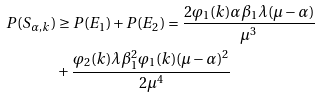<formula> <loc_0><loc_0><loc_500><loc_500>P ( S _ { \alpha , k } ) & \geq P ( E _ { 1 } ) + P ( E _ { 2 } ) = \frac { 2 \varphi _ { 1 } ( k ) \alpha \beta _ { 1 } \lambda ( \mu - \alpha ) } { \mu ^ { 3 } } \\ & + \frac { \varphi _ { 2 } ( k ) \lambda \beta _ { 1 } ^ { 2 } \varphi _ { 1 } ( k ) ( \mu - \alpha ) ^ { 2 } } { 2 \mu ^ { 4 } }</formula> 